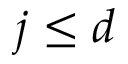<formula> <loc_0><loc_0><loc_500><loc_500>j \leq d</formula> 